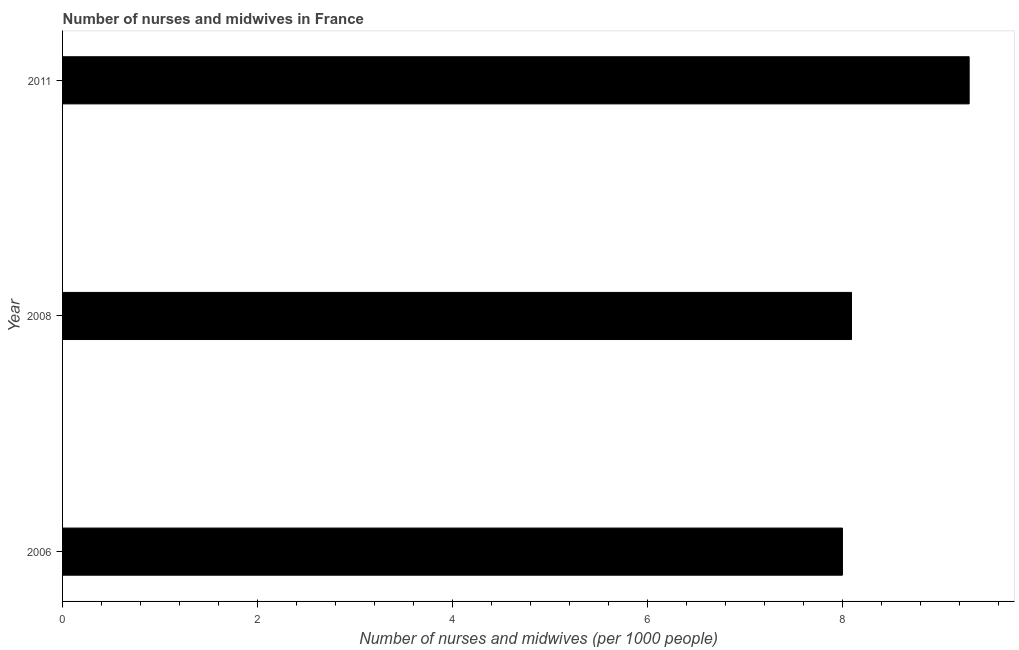What is the title of the graph?
Provide a short and direct response. Number of nurses and midwives in France. What is the label or title of the X-axis?
Give a very brief answer. Number of nurses and midwives (per 1000 people). What is the number of nurses and midwives in 2011?
Your answer should be very brief. 9.3. Across all years, what is the maximum number of nurses and midwives?
Your answer should be compact. 9.3. In which year was the number of nurses and midwives maximum?
Ensure brevity in your answer.  2011. What is the sum of the number of nurses and midwives?
Offer a terse response. 25.39. What is the difference between the number of nurses and midwives in 2006 and 2008?
Give a very brief answer. -0.09. What is the average number of nurses and midwives per year?
Your answer should be compact. 8.46. What is the median number of nurses and midwives?
Offer a very short reply. 8.09. In how many years, is the number of nurses and midwives greater than 1.6 ?
Provide a succinct answer. 3. Do a majority of the years between 2006 and 2011 (inclusive) have number of nurses and midwives greater than 3.6 ?
Ensure brevity in your answer.  Yes. What is the ratio of the number of nurses and midwives in 2006 to that in 2011?
Provide a succinct answer. 0.86. Is the difference between the number of nurses and midwives in 2006 and 2008 greater than the difference between any two years?
Ensure brevity in your answer.  No. What is the difference between the highest and the second highest number of nurses and midwives?
Provide a succinct answer. 1.21. Is the sum of the number of nurses and midwives in 2006 and 2011 greater than the maximum number of nurses and midwives across all years?
Provide a short and direct response. Yes. Are all the bars in the graph horizontal?
Your response must be concise. Yes. How many years are there in the graph?
Keep it short and to the point. 3. What is the Number of nurses and midwives (per 1000 people) of 2006?
Offer a terse response. 8. What is the Number of nurses and midwives (per 1000 people) of 2008?
Ensure brevity in your answer.  8.09. What is the difference between the Number of nurses and midwives (per 1000 people) in 2006 and 2008?
Your answer should be very brief. -0.09. What is the difference between the Number of nurses and midwives (per 1000 people) in 2006 and 2011?
Keep it short and to the point. -1.3. What is the difference between the Number of nurses and midwives (per 1000 people) in 2008 and 2011?
Give a very brief answer. -1.21. What is the ratio of the Number of nurses and midwives (per 1000 people) in 2006 to that in 2008?
Your answer should be very brief. 0.99. What is the ratio of the Number of nurses and midwives (per 1000 people) in 2006 to that in 2011?
Keep it short and to the point. 0.86. What is the ratio of the Number of nurses and midwives (per 1000 people) in 2008 to that in 2011?
Offer a terse response. 0.87. 